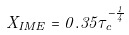<formula> <loc_0><loc_0><loc_500><loc_500>X _ { I M E } = 0 . 3 5 \tau _ { c } ^ { - \frac { 1 } { 4 } }</formula> 